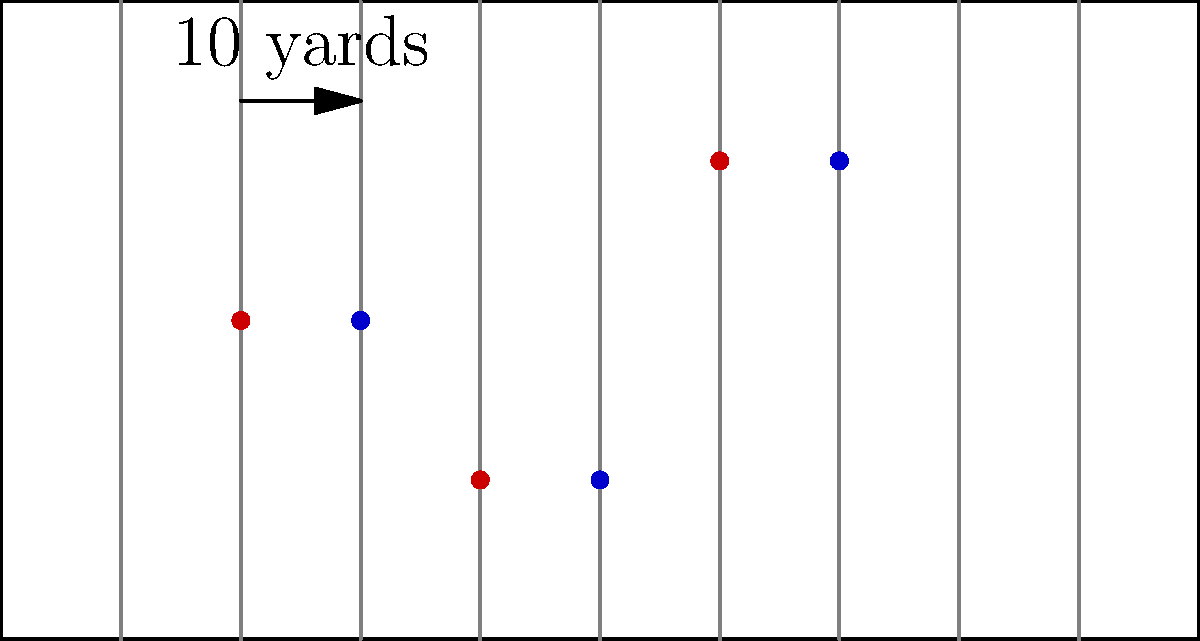In the diagram above, the red dots represent the initial positions of three players from Team A on a football field. If Team B's defensive formation is a direct translation of Team A's formation by 10 yards to the right, what would be the coordinates of Team B's middle player (represented by the blue dot) after the translation? To solve this problem, we need to follow these steps:

1. Identify the initial coordinates of Team A's middle player (the red dot in the middle):
   The middle red dot is at (40, 13.325)

2. Understand the translation:
   The formation is translated 10 yards to the right, which means we add 10 to the x-coordinate.

3. Apply the translation:
   New x-coordinate = 40 + 10 = 50
   The y-coordinate remains unchanged at 13.325

4. Express the final coordinates:
   The coordinates of Team B's middle player after translation are (50, 13.325)

In the context of football field dimensions:
- The x-coordinate 50 represents the 50-yard line
- The y-coordinate 13.325 represents approximately 13.3 yards from the sideline

This translation maintains the same formation shape while moving it 10 yards down the field, which is a common defensive strategy to mirror the offensive formation.
Answer: (50, 13.325) 